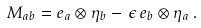<formula> <loc_0><loc_0><loc_500><loc_500>M _ { a b } = e _ { a } \otimes \eta _ { b } - \, \epsilon \, e _ { b } \otimes \eta _ { a } \, .</formula> 